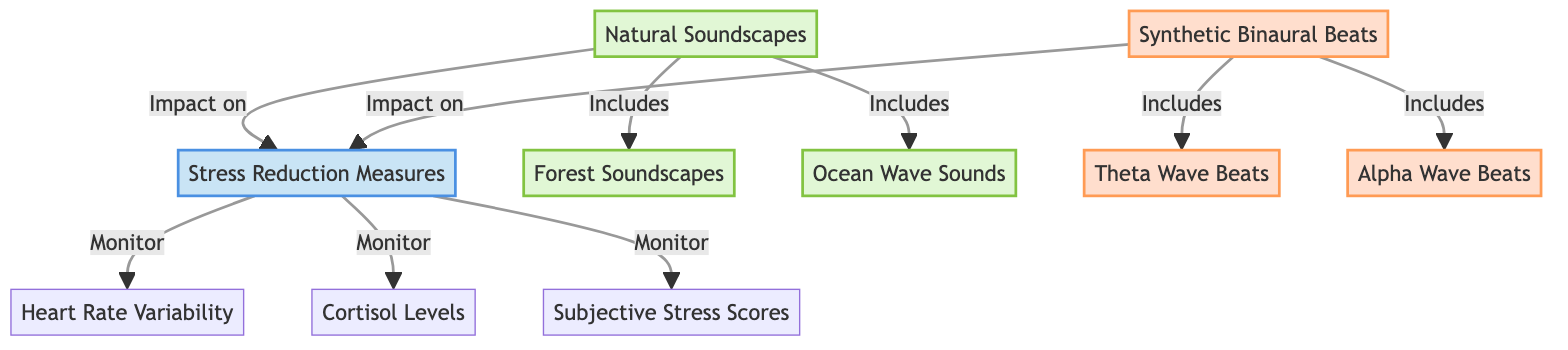What are the two main types of sound sources shown in the diagram? The diagram includes Natural Soundscapes and Synthetic Binaural Beats as the two main sound sources.
Answer: Natural Soundscapes and Synthetic Binaural Beats How many measures of stress reduction are monitored in the diagram? The diagram displays three measures of stress reduction that are monitored: Heart Rate Variability, Cortisol Levels, and Subjective Stress Scores.
Answer: Three Which natural soundscape includes forest sounds? The diagram specifies that Forest Soundscapes is a part of the Natural Soundscapes.
Answer: Forest Soundscapes What impact do both Natural Soundscapes and Synthetic Binaural Beats have? Both types of sound sources impact Stress Reduction Measures, as indicated by the arrows pointing from both nodes to the SRM node.
Answer: Stress Reduction Measures What sounds are categorized as Synthetic Binaural Beats? The diagram lists Theta Wave Beats and Alpha Wave Beats as the sounds included in Synthetic Binaural Beats.
Answer: Theta Wave Beats and Alpha Wave Beats Which measure is affected by both types of sound sources? The Stress Reduction Measures (SRM) is the common measure affected by both Natural Soundscapes and Synthetic Binaural Beats, linking them together in the diagram.
Answer: Stress Reduction Measures How are the natural soundscapes related to their components? Natural Soundscapes are linked to its components, such as Forest Soundscapes and Ocean Wave Sounds, indicating that these sounds fall under Natural Soundscapes.
Answer: Includes What node monitors cortisol levels in the diagram? Cortisol Levels is one of the measures listed under Stress Reduction Measures, which is monitored in the diagram.
Answer: Cortisol Levels Which type of sound source is associated with environmental nature? Natural Soundscapes represent the types of sound sources associated with environmental nature, as indicated by its designation in the diagram.
Answer: Natural Soundscapes 